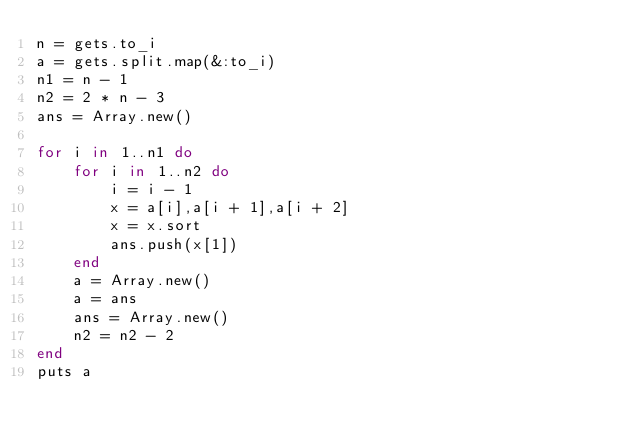Convert code to text. <code><loc_0><loc_0><loc_500><loc_500><_Ruby_>n = gets.to_i
a = gets.split.map(&:to_i)
n1 = n - 1
n2 = 2 * n - 3
ans = Array.new()

for i in 1..n1 do
	for i in 1..n2 do
		i = i - 1
		x = a[i],a[i + 1],a[i + 2]
		x = x.sort
		ans.push(x[1])
	end
	a = Array.new()
	a = ans
	ans = Array.new()
	n2 = n2 - 2
end
puts a
</code> 